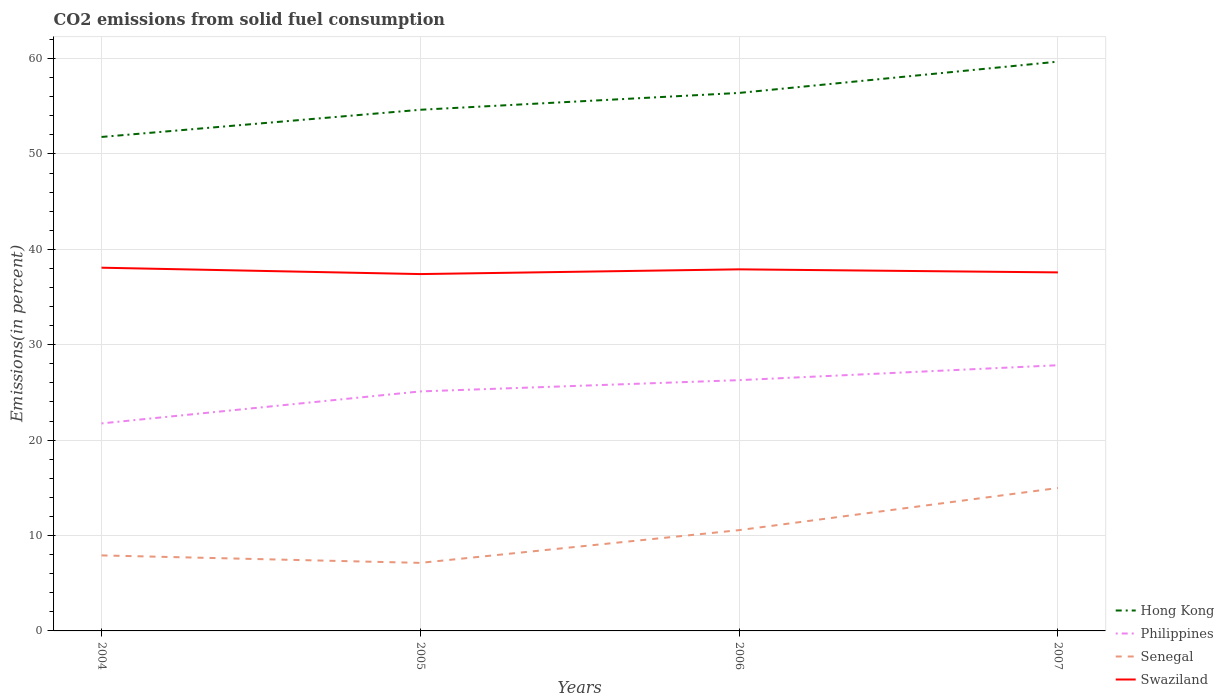How many different coloured lines are there?
Your response must be concise. 4. Is the number of lines equal to the number of legend labels?
Offer a terse response. Yes. Across all years, what is the maximum total CO2 emitted in Senegal?
Your answer should be very brief. 7.13. In which year was the total CO2 emitted in Swaziland maximum?
Give a very brief answer. 2005. What is the total total CO2 emitted in Hong Kong in the graph?
Give a very brief answer. -1.77. What is the difference between the highest and the second highest total CO2 emitted in Philippines?
Offer a very short reply. 6.1. What is the difference between the highest and the lowest total CO2 emitted in Senegal?
Make the answer very short. 2. How many lines are there?
Offer a terse response. 4. How many years are there in the graph?
Keep it short and to the point. 4. What is the difference between two consecutive major ticks on the Y-axis?
Offer a very short reply. 10. Does the graph contain any zero values?
Offer a very short reply. No. Where does the legend appear in the graph?
Give a very brief answer. Bottom right. How many legend labels are there?
Offer a terse response. 4. What is the title of the graph?
Ensure brevity in your answer.  CO2 emissions from solid fuel consumption. Does "South Africa" appear as one of the legend labels in the graph?
Give a very brief answer. No. What is the label or title of the X-axis?
Your response must be concise. Years. What is the label or title of the Y-axis?
Keep it short and to the point. Emissions(in percent). What is the Emissions(in percent) in Hong Kong in 2004?
Offer a very short reply. 51.79. What is the Emissions(in percent) in Philippines in 2004?
Offer a terse response. 21.75. What is the Emissions(in percent) of Senegal in 2004?
Ensure brevity in your answer.  7.92. What is the Emissions(in percent) in Swaziland in 2004?
Your answer should be compact. 38.08. What is the Emissions(in percent) of Hong Kong in 2005?
Make the answer very short. 54.64. What is the Emissions(in percent) in Philippines in 2005?
Offer a terse response. 25.11. What is the Emissions(in percent) in Senegal in 2005?
Keep it short and to the point. 7.13. What is the Emissions(in percent) of Swaziland in 2005?
Provide a short and direct response. 37.41. What is the Emissions(in percent) in Hong Kong in 2006?
Ensure brevity in your answer.  56.4. What is the Emissions(in percent) of Philippines in 2006?
Provide a short and direct response. 26.29. What is the Emissions(in percent) of Senegal in 2006?
Give a very brief answer. 10.57. What is the Emissions(in percent) of Swaziland in 2006?
Offer a very short reply. 37.91. What is the Emissions(in percent) in Hong Kong in 2007?
Your answer should be very brief. 59.68. What is the Emissions(in percent) in Philippines in 2007?
Ensure brevity in your answer.  27.85. What is the Emissions(in percent) in Senegal in 2007?
Offer a terse response. 14.98. What is the Emissions(in percent) in Swaziland in 2007?
Ensure brevity in your answer.  37.59. Across all years, what is the maximum Emissions(in percent) of Hong Kong?
Offer a terse response. 59.68. Across all years, what is the maximum Emissions(in percent) in Philippines?
Give a very brief answer. 27.85. Across all years, what is the maximum Emissions(in percent) in Senegal?
Make the answer very short. 14.98. Across all years, what is the maximum Emissions(in percent) in Swaziland?
Keep it short and to the point. 38.08. Across all years, what is the minimum Emissions(in percent) in Hong Kong?
Your answer should be compact. 51.79. Across all years, what is the minimum Emissions(in percent) of Philippines?
Your response must be concise. 21.75. Across all years, what is the minimum Emissions(in percent) in Senegal?
Your response must be concise. 7.13. Across all years, what is the minimum Emissions(in percent) of Swaziland?
Provide a short and direct response. 37.41. What is the total Emissions(in percent) in Hong Kong in the graph?
Ensure brevity in your answer.  222.5. What is the total Emissions(in percent) of Philippines in the graph?
Provide a short and direct response. 101.01. What is the total Emissions(in percent) of Senegal in the graph?
Provide a short and direct response. 40.6. What is the total Emissions(in percent) of Swaziland in the graph?
Ensure brevity in your answer.  150.98. What is the difference between the Emissions(in percent) in Hong Kong in 2004 and that in 2005?
Offer a terse response. -2.85. What is the difference between the Emissions(in percent) of Philippines in 2004 and that in 2005?
Give a very brief answer. -3.35. What is the difference between the Emissions(in percent) in Senegal in 2004 and that in 2005?
Offer a terse response. 0.78. What is the difference between the Emissions(in percent) in Swaziland in 2004 and that in 2005?
Your answer should be very brief. 0.67. What is the difference between the Emissions(in percent) in Hong Kong in 2004 and that in 2006?
Provide a succinct answer. -4.62. What is the difference between the Emissions(in percent) of Philippines in 2004 and that in 2006?
Your response must be concise. -4.53. What is the difference between the Emissions(in percent) in Senegal in 2004 and that in 2006?
Provide a succinct answer. -2.65. What is the difference between the Emissions(in percent) in Swaziland in 2004 and that in 2006?
Provide a short and direct response. 0.17. What is the difference between the Emissions(in percent) in Hong Kong in 2004 and that in 2007?
Provide a short and direct response. -7.9. What is the difference between the Emissions(in percent) in Philippines in 2004 and that in 2007?
Ensure brevity in your answer.  -6.1. What is the difference between the Emissions(in percent) of Senegal in 2004 and that in 2007?
Give a very brief answer. -7.07. What is the difference between the Emissions(in percent) in Swaziland in 2004 and that in 2007?
Provide a succinct answer. 0.49. What is the difference between the Emissions(in percent) in Hong Kong in 2005 and that in 2006?
Provide a short and direct response. -1.77. What is the difference between the Emissions(in percent) in Philippines in 2005 and that in 2006?
Provide a short and direct response. -1.18. What is the difference between the Emissions(in percent) of Senegal in 2005 and that in 2006?
Provide a succinct answer. -3.43. What is the difference between the Emissions(in percent) in Swaziland in 2005 and that in 2006?
Your answer should be very brief. -0.5. What is the difference between the Emissions(in percent) in Hong Kong in 2005 and that in 2007?
Your answer should be compact. -5.05. What is the difference between the Emissions(in percent) of Philippines in 2005 and that in 2007?
Keep it short and to the point. -2.75. What is the difference between the Emissions(in percent) in Senegal in 2005 and that in 2007?
Keep it short and to the point. -7.85. What is the difference between the Emissions(in percent) of Swaziland in 2005 and that in 2007?
Give a very brief answer. -0.18. What is the difference between the Emissions(in percent) of Hong Kong in 2006 and that in 2007?
Keep it short and to the point. -3.28. What is the difference between the Emissions(in percent) of Philippines in 2006 and that in 2007?
Your answer should be compact. -1.56. What is the difference between the Emissions(in percent) of Senegal in 2006 and that in 2007?
Your answer should be very brief. -4.42. What is the difference between the Emissions(in percent) of Swaziland in 2006 and that in 2007?
Your answer should be compact. 0.32. What is the difference between the Emissions(in percent) of Hong Kong in 2004 and the Emissions(in percent) of Philippines in 2005?
Keep it short and to the point. 26.68. What is the difference between the Emissions(in percent) in Hong Kong in 2004 and the Emissions(in percent) in Senegal in 2005?
Your answer should be very brief. 44.65. What is the difference between the Emissions(in percent) in Hong Kong in 2004 and the Emissions(in percent) in Swaziland in 2005?
Your answer should be compact. 14.38. What is the difference between the Emissions(in percent) of Philippines in 2004 and the Emissions(in percent) of Senegal in 2005?
Offer a terse response. 14.62. What is the difference between the Emissions(in percent) of Philippines in 2004 and the Emissions(in percent) of Swaziland in 2005?
Give a very brief answer. -15.66. What is the difference between the Emissions(in percent) of Senegal in 2004 and the Emissions(in percent) of Swaziland in 2005?
Offer a very short reply. -29.49. What is the difference between the Emissions(in percent) in Hong Kong in 2004 and the Emissions(in percent) in Philippines in 2006?
Your response must be concise. 25.5. What is the difference between the Emissions(in percent) of Hong Kong in 2004 and the Emissions(in percent) of Senegal in 2006?
Provide a short and direct response. 41.22. What is the difference between the Emissions(in percent) of Hong Kong in 2004 and the Emissions(in percent) of Swaziland in 2006?
Offer a terse response. 13.88. What is the difference between the Emissions(in percent) in Philippines in 2004 and the Emissions(in percent) in Senegal in 2006?
Provide a short and direct response. 11.19. What is the difference between the Emissions(in percent) of Philippines in 2004 and the Emissions(in percent) of Swaziland in 2006?
Ensure brevity in your answer.  -16.15. What is the difference between the Emissions(in percent) of Senegal in 2004 and the Emissions(in percent) of Swaziland in 2006?
Offer a terse response. -29.99. What is the difference between the Emissions(in percent) in Hong Kong in 2004 and the Emissions(in percent) in Philippines in 2007?
Provide a succinct answer. 23.93. What is the difference between the Emissions(in percent) in Hong Kong in 2004 and the Emissions(in percent) in Senegal in 2007?
Your response must be concise. 36.8. What is the difference between the Emissions(in percent) in Hong Kong in 2004 and the Emissions(in percent) in Swaziland in 2007?
Keep it short and to the point. 14.2. What is the difference between the Emissions(in percent) of Philippines in 2004 and the Emissions(in percent) of Senegal in 2007?
Provide a succinct answer. 6.77. What is the difference between the Emissions(in percent) in Philippines in 2004 and the Emissions(in percent) in Swaziland in 2007?
Your answer should be compact. -15.83. What is the difference between the Emissions(in percent) in Senegal in 2004 and the Emissions(in percent) in Swaziland in 2007?
Provide a succinct answer. -29.67. What is the difference between the Emissions(in percent) of Hong Kong in 2005 and the Emissions(in percent) of Philippines in 2006?
Keep it short and to the point. 28.35. What is the difference between the Emissions(in percent) in Hong Kong in 2005 and the Emissions(in percent) in Senegal in 2006?
Your answer should be compact. 44.07. What is the difference between the Emissions(in percent) of Hong Kong in 2005 and the Emissions(in percent) of Swaziland in 2006?
Your response must be concise. 16.73. What is the difference between the Emissions(in percent) of Philippines in 2005 and the Emissions(in percent) of Senegal in 2006?
Make the answer very short. 14.54. What is the difference between the Emissions(in percent) in Philippines in 2005 and the Emissions(in percent) in Swaziland in 2006?
Ensure brevity in your answer.  -12.8. What is the difference between the Emissions(in percent) of Senegal in 2005 and the Emissions(in percent) of Swaziland in 2006?
Your response must be concise. -30.77. What is the difference between the Emissions(in percent) in Hong Kong in 2005 and the Emissions(in percent) in Philippines in 2007?
Offer a very short reply. 26.78. What is the difference between the Emissions(in percent) of Hong Kong in 2005 and the Emissions(in percent) of Senegal in 2007?
Provide a short and direct response. 39.65. What is the difference between the Emissions(in percent) of Hong Kong in 2005 and the Emissions(in percent) of Swaziland in 2007?
Provide a short and direct response. 17.05. What is the difference between the Emissions(in percent) in Philippines in 2005 and the Emissions(in percent) in Senegal in 2007?
Give a very brief answer. 10.13. What is the difference between the Emissions(in percent) of Philippines in 2005 and the Emissions(in percent) of Swaziland in 2007?
Provide a succinct answer. -12.48. What is the difference between the Emissions(in percent) of Senegal in 2005 and the Emissions(in percent) of Swaziland in 2007?
Ensure brevity in your answer.  -30.45. What is the difference between the Emissions(in percent) of Hong Kong in 2006 and the Emissions(in percent) of Philippines in 2007?
Offer a very short reply. 28.55. What is the difference between the Emissions(in percent) in Hong Kong in 2006 and the Emissions(in percent) in Senegal in 2007?
Keep it short and to the point. 41.42. What is the difference between the Emissions(in percent) of Hong Kong in 2006 and the Emissions(in percent) of Swaziland in 2007?
Provide a short and direct response. 18.81. What is the difference between the Emissions(in percent) in Philippines in 2006 and the Emissions(in percent) in Senegal in 2007?
Give a very brief answer. 11.31. What is the difference between the Emissions(in percent) in Philippines in 2006 and the Emissions(in percent) in Swaziland in 2007?
Offer a terse response. -11.3. What is the difference between the Emissions(in percent) of Senegal in 2006 and the Emissions(in percent) of Swaziland in 2007?
Your answer should be very brief. -27.02. What is the average Emissions(in percent) in Hong Kong per year?
Make the answer very short. 55.63. What is the average Emissions(in percent) in Philippines per year?
Your response must be concise. 25.25. What is the average Emissions(in percent) in Senegal per year?
Keep it short and to the point. 10.15. What is the average Emissions(in percent) in Swaziland per year?
Make the answer very short. 37.75. In the year 2004, what is the difference between the Emissions(in percent) in Hong Kong and Emissions(in percent) in Philippines?
Make the answer very short. 30.03. In the year 2004, what is the difference between the Emissions(in percent) in Hong Kong and Emissions(in percent) in Senegal?
Your answer should be compact. 43.87. In the year 2004, what is the difference between the Emissions(in percent) in Hong Kong and Emissions(in percent) in Swaziland?
Offer a very short reply. 13.71. In the year 2004, what is the difference between the Emissions(in percent) of Philippines and Emissions(in percent) of Senegal?
Your answer should be very brief. 13.84. In the year 2004, what is the difference between the Emissions(in percent) of Philippines and Emissions(in percent) of Swaziland?
Provide a succinct answer. -16.32. In the year 2004, what is the difference between the Emissions(in percent) in Senegal and Emissions(in percent) in Swaziland?
Your answer should be very brief. -30.16. In the year 2005, what is the difference between the Emissions(in percent) in Hong Kong and Emissions(in percent) in Philippines?
Provide a succinct answer. 29.53. In the year 2005, what is the difference between the Emissions(in percent) of Hong Kong and Emissions(in percent) of Senegal?
Your answer should be compact. 47.5. In the year 2005, what is the difference between the Emissions(in percent) in Hong Kong and Emissions(in percent) in Swaziland?
Provide a succinct answer. 17.23. In the year 2005, what is the difference between the Emissions(in percent) of Philippines and Emissions(in percent) of Senegal?
Keep it short and to the point. 17.98. In the year 2005, what is the difference between the Emissions(in percent) in Philippines and Emissions(in percent) in Swaziland?
Your response must be concise. -12.3. In the year 2005, what is the difference between the Emissions(in percent) of Senegal and Emissions(in percent) of Swaziland?
Keep it short and to the point. -30.28. In the year 2006, what is the difference between the Emissions(in percent) of Hong Kong and Emissions(in percent) of Philippines?
Your answer should be compact. 30.11. In the year 2006, what is the difference between the Emissions(in percent) in Hong Kong and Emissions(in percent) in Senegal?
Your answer should be very brief. 45.83. In the year 2006, what is the difference between the Emissions(in percent) in Hong Kong and Emissions(in percent) in Swaziland?
Provide a succinct answer. 18.49. In the year 2006, what is the difference between the Emissions(in percent) of Philippines and Emissions(in percent) of Senegal?
Make the answer very short. 15.72. In the year 2006, what is the difference between the Emissions(in percent) in Philippines and Emissions(in percent) in Swaziland?
Provide a short and direct response. -11.62. In the year 2006, what is the difference between the Emissions(in percent) in Senegal and Emissions(in percent) in Swaziland?
Ensure brevity in your answer.  -27.34. In the year 2007, what is the difference between the Emissions(in percent) in Hong Kong and Emissions(in percent) in Philippines?
Ensure brevity in your answer.  31.83. In the year 2007, what is the difference between the Emissions(in percent) of Hong Kong and Emissions(in percent) of Senegal?
Offer a terse response. 44.7. In the year 2007, what is the difference between the Emissions(in percent) in Hong Kong and Emissions(in percent) in Swaziland?
Offer a very short reply. 22.09. In the year 2007, what is the difference between the Emissions(in percent) of Philippines and Emissions(in percent) of Senegal?
Your answer should be compact. 12.87. In the year 2007, what is the difference between the Emissions(in percent) of Philippines and Emissions(in percent) of Swaziland?
Your answer should be compact. -9.73. In the year 2007, what is the difference between the Emissions(in percent) in Senegal and Emissions(in percent) in Swaziland?
Your response must be concise. -22.6. What is the ratio of the Emissions(in percent) in Hong Kong in 2004 to that in 2005?
Give a very brief answer. 0.95. What is the ratio of the Emissions(in percent) of Philippines in 2004 to that in 2005?
Provide a succinct answer. 0.87. What is the ratio of the Emissions(in percent) of Senegal in 2004 to that in 2005?
Your answer should be very brief. 1.11. What is the ratio of the Emissions(in percent) in Swaziland in 2004 to that in 2005?
Give a very brief answer. 1.02. What is the ratio of the Emissions(in percent) in Hong Kong in 2004 to that in 2006?
Your answer should be compact. 0.92. What is the ratio of the Emissions(in percent) of Philippines in 2004 to that in 2006?
Your answer should be very brief. 0.83. What is the ratio of the Emissions(in percent) in Senegal in 2004 to that in 2006?
Ensure brevity in your answer.  0.75. What is the ratio of the Emissions(in percent) of Swaziland in 2004 to that in 2006?
Offer a terse response. 1. What is the ratio of the Emissions(in percent) in Hong Kong in 2004 to that in 2007?
Ensure brevity in your answer.  0.87. What is the ratio of the Emissions(in percent) of Philippines in 2004 to that in 2007?
Your answer should be very brief. 0.78. What is the ratio of the Emissions(in percent) of Senegal in 2004 to that in 2007?
Your response must be concise. 0.53. What is the ratio of the Emissions(in percent) of Swaziland in 2004 to that in 2007?
Ensure brevity in your answer.  1.01. What is the ratio of the Emissions(in percent) in Hong Kong in 2005 to that in 2006?
Give a very brief answer. 0.97. What is the ratio of the Emissions(in percent) of Philippines in 2005 to that in 2006?
Your answer should be compact. 0.96. What is the ratio of the Emissions(in percent) in Senegal in 2005 to that in 2006?
Offer a terse response. 0.68. What is the ratio of the Emissions(in percent) of Swaziland in 2005 to that in 2006?
Keep it short and to the point. 0.99. What is the ratio of the Emissions(in percent) of Hong Kong in 2005 to that in 2007?
Give a very brief answer. 0.92. What is the ratio of the Emissions(in percent) in Philippines in 2005 to that in 2007?
Provide a succinct answer. 0.9. What is the ratio of the Emissions(in percent) of Senegal in 2005 to that in 2007?
Keep it short and to the point. 0.48. What is the ratio of the Emissions(in percent) of Swaziland in 2005 to that in 2007?
Give a very brief answer. 1. What is the ratio of the Emissions(in percent) in Hong Kong in 2006 to that in 2007?
Offer a very short reply. 0.94. What is the ratio of the Emissions(in percent) in Philippines in 2006 to that in 2007?
Keep it short and to the point. 0.94. What is the ratio of the Emissions(in percent) in Senegal in 2006 to that in 2007?
Ensure brevity in your answer.  0.71. What is the ratio of the Emissions(in percent) in Swaziland in 2006 to that in 2007?
Provide a succinct answer. 1.01. What is the difference between the highest and the second highest Emissions(in percent) of Hong Kong?
Offer a very short reply. 3.28. What is the difference between the highest and the second highest Emissions(in percent) in Philippines?
Offer a terse response. 1.56. What is the difference between the highest and the second highest Emissions(in percent) in Senegal?
Offer a very short reply. 4.42. What is the difference between the highest and the second highest Emissions(in percent) of Swaziland?
Ensure brevity in your answer.  0.17. What is the difference between the highest and the lowest Emissions(in percent) of Hong Kong?
Ensure brevity in your answer.  7.9. What is the difference between the highest and the lowest Emissions(in percent) of Philippines?
Provide a succinct answer. 6.1. What is the difference between the highest and the lowest Emissions(in percent) in Senegal?
Your answer should be compact. 7.85. What is the difference between the highest and the lowest Emissions(in percent) in Swaziland?
Offer a terse response. 0.67. 